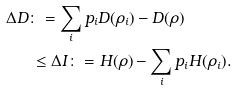<formula> <loc_0><loc_0><loc_500><loc_500>\Delta D & \colon = \sum _ { i } p _ { i } D ( \rho _ { i } ) - D ( \rho ) \\ & \, \leq \Delta I \colon = H ( \rho ) - \sum _ { i } p _ { i } H ( \rho _ { i } ) .</formula> 